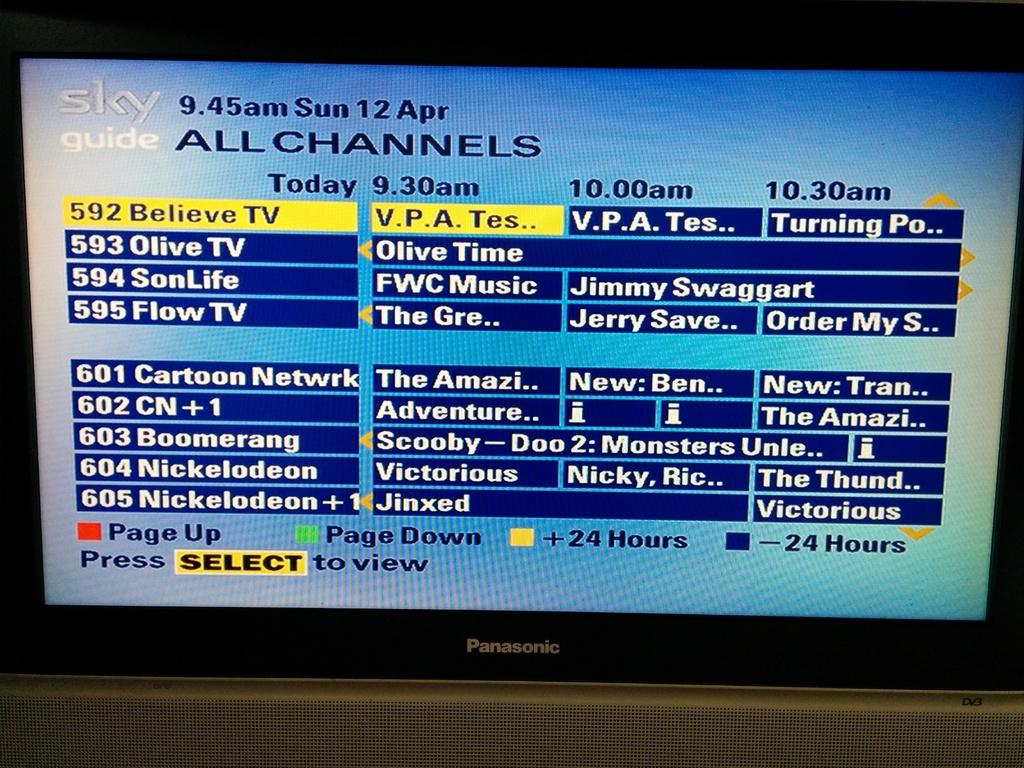What electronic device can be seen in the image? There is a television in the image. What is displayed on the television screen? There is text visible on the television screen. How many legs does the donkey have in the image? There is no donkey present in the image. What is the name of the son who appears in the image? There is no person, let alone a son, present in the image. 